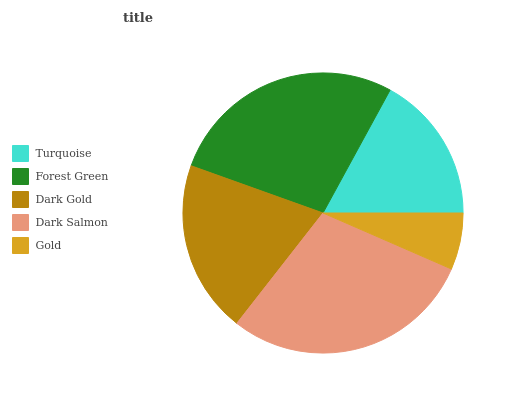Is Gold the minimum?
Answer yes or no. Yes. Is Dark Salmon the maximum?
Answer yes or no. Yes. Is Forest Green the minimum?
Answer yes or no. No. Is Forest Green the maximum?
Answer yes or no. No. Is Forest Green greater than Turquoise?
Answer yes or no. Yes. Is Turquoise less than Forest Green?
Answer yes or no. Yes. Is Turquoise greater than Forest Green?
Answer yes or no. No. Is Forest Green less than Turquoise?
Answer yes or no. No. Is Dark Gold the high median?
Answer yes or no. Yes. Is Dark Gold the low median?
Answer yes or no. Yes. Is Turquoise the high median?
Answer yes or no. No. Is Dark Salmon the low median?
Answer yes or no. No. 